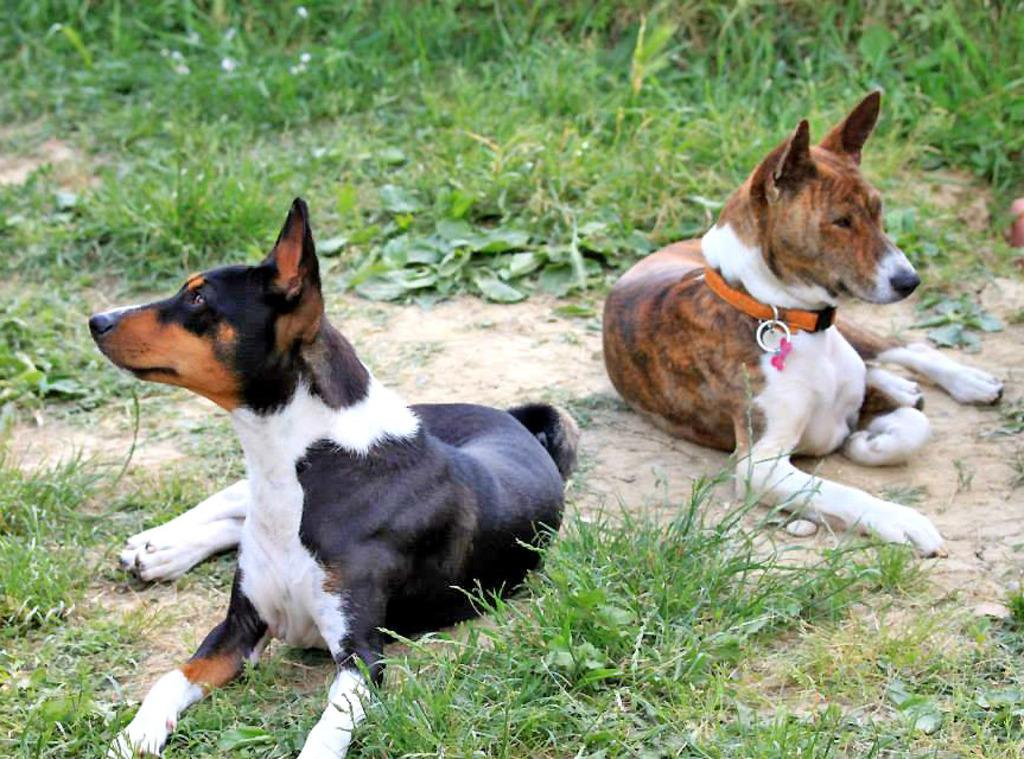What type of animals are in the image? There are dogs in the image. What position are the dogs in? The dogs are sitting on the ground. What can be seen in the background of the image? There is grass visible in the background of the image. What subject is the minister teaching in the image? There is no minister or teaching activity present in the image; it features dogs sitting on the ground. How many geese are visible in the image? There are no geese present in the image. 